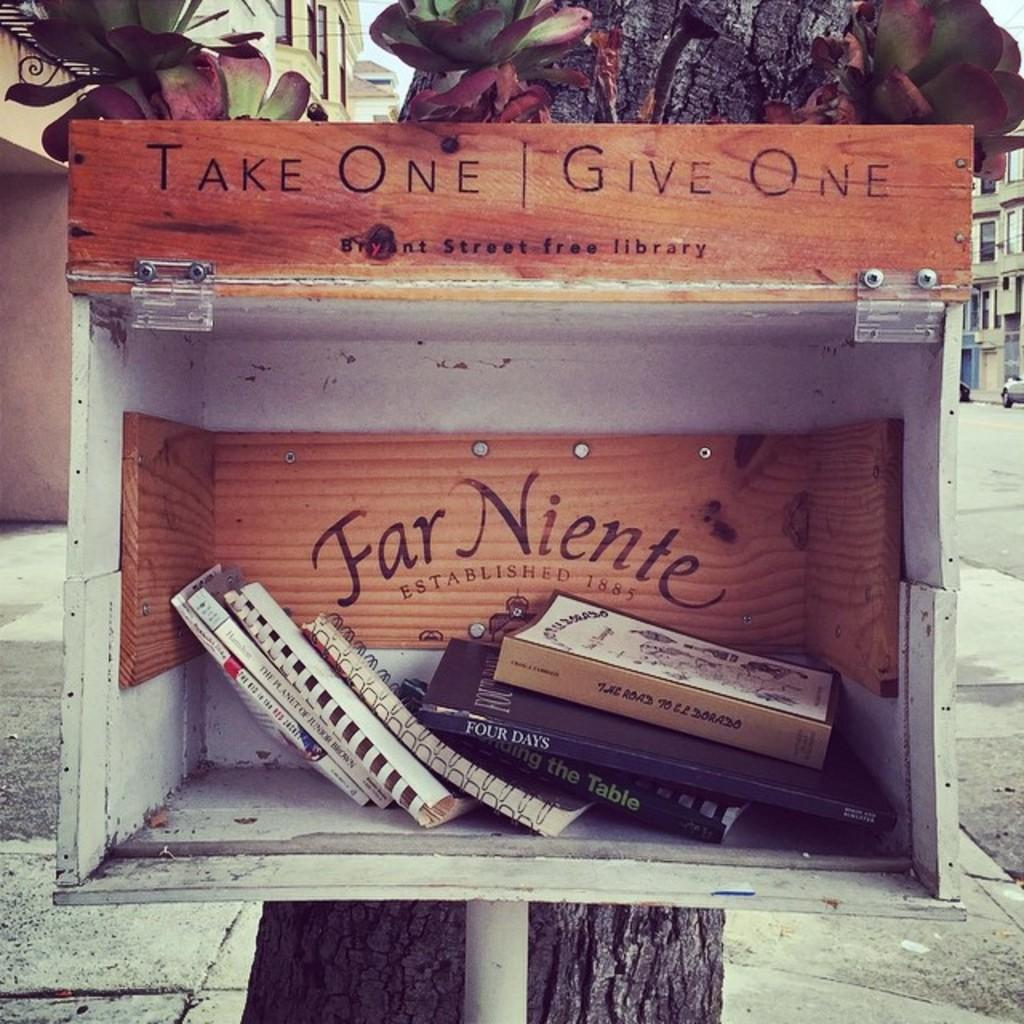Provide a one-sentence caption for the provided image. A box that says Take One Give One contains a number of books. 